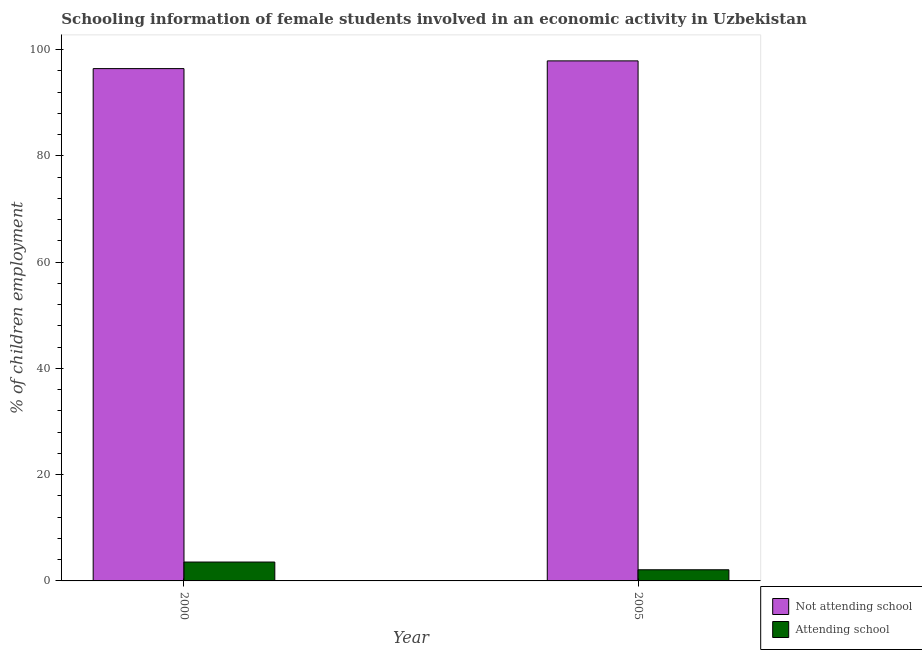How many different coloured bars are there?
Provide a short and direct response. 2. How many groups of bars are there?
Your answer should be compact. 2. In how many cases, is the number of bars for a given year not equal to the number of legend labels?
Provide a short and direct response. 0. What is the percentage of employed females who are not attending school in 2000?
Offer a terse response. 96.45. Across all years, what is the maximum percentage of employed females who are attending school?
Your answer should be very brief. 3.55. What is the total percentage of employed females who are not attending school in the graph?
Provide a succinct answer. 194.35. What is the difference between the percentage of employed females who are not attending school in 2000 and that in 2005?
Provide a short and direct response. -1.45. What is the difference between the percentage of employed females who are not attending school in 2005 and the percentage of employed females who are attending school in 2000?
Your answer should be compact. 1.45. What is the average percentage of employed females who are not attending school per year?
Provide a succinct answer. 97.17. What is the ratio of the percentage of employed females who are attending school in 2000 to that in 2005?
Make the answer very short. 1.69. In how many years, is the percentage of employed females who are attending school greater than the average percentage of employed females who are attending school taken over all years?
Your answer should be very brief. 1. What does the 1st bar from the left in 2000 represents?
Your response must be concise. Not attending school. What does the 1st bar from the right in 2000 represents?
Provide a succinct answer. Attending school. How many bars are there?
Your answer should be very brief. 4. Where does the legend appear in the graph?
Provide a short and direct response. Bottom right. How are the legend labels stacked?
Give a very brief answer. Vertical. What is the title of the graph?
Your answer should be very brief. Schooling information of female students involved in an economic activity in Uzbekistan. What is the label or title of the X-axis?
Provide a succinct answer. Year. What is the label or title of the Y-axis?
Offer a very short reply. % of children employment. What is the % of children employment of Not attending school in 2000?
Make the answer very short. 96.45. What is the % of children employment of Attending school in 2000?
Offer a very short reply. 3.55. What is the % of children employment in Not attending school in 2005?
Provide a short and direct response. 97.9. Across all years, what is the maximum % of children employment of Not attending school?
Give a very brief answer. 97.9. Across all years, what is the maximum % of children employment in Attending school?
Make the answer very short. 3.55. Across all years, what is the minimum % of children employment in Not attending school?
Your response must be concise. 96.45. Across all years, what is the minimum % of children employment in Attending school?
Make the answer very short. 2.1. What is the total % of children employment in Not attending school in the graph?
Offer a terse response. 194.35. What is the total % of children employment of Attending school in the graph?
Offer a very short reply. 5.65. What is the difference between the % of children employment in Not attending school in 2000 and that in 2005?
Make the answer very short. -1.45. What is the difference between the % of children employment in Attending school in 2000 and that in 2005?
Provide a succinct answer. 1.45. What is the difference between the % of children employment in Not attending school in 2000 and the % of children employment in Attending school in 2005?
Make the answer very short. 94.35. What is the average % of children employment in Not attending school per year?
Your response must be concise. 97.17. What is the average % of children employment in Attending school per year?
Keep it short and to the point. 2.83. In the year 2000, what is the difference between the % of children employment of Not attending school and % of children employment of Attending school?
Make the answer very short. 92.89. In the year 2005, what is the difference between the % of children employment of Not attending school and % of children employment of Attending school?
Your response must be concise. 95.8. What is the ratio of the % of children employment of Not attending school in 2000 to that in 2005?
Your answer should be very brief. 0.99. What is the ratio of the % of children employment of Attending school in 2000 to that in 2005?
Give a very brief answer. 1.69. What is the difference between the highest and the second highest % of children employment of Not attending school?
Make the answer very short. 1.45. What is the difference between the highest and the second highest % of children employment of Attending school?
Provide a succinct answer. 1.45. What is the difference between the highest and the lowest % of children employment of Not attending school?
Your response must be concise. 1.45. What is the difference between the highest and the lowest % of children employment of Attending school?
Provide a short and direct response. 1.45. 